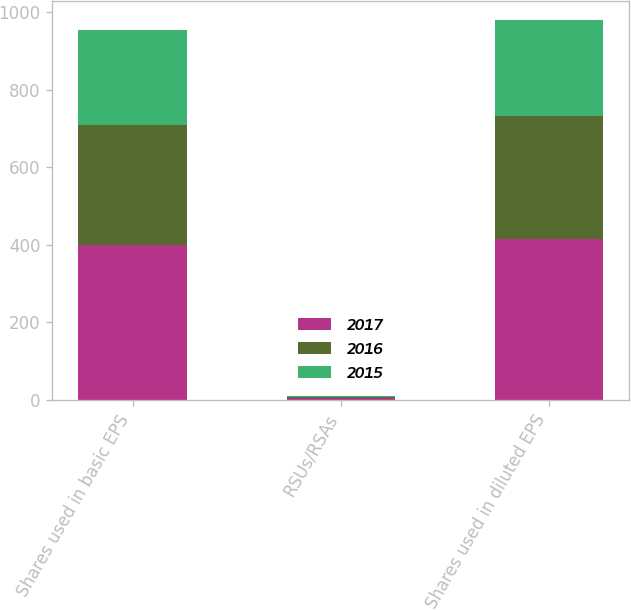Convert chart to OTSL. <chart><loc_0><loc_0><loc_500><loc_500><stacked_bar_chart><ecel><fcel>Shares used in basic EPS<fcel>RSUs/RSAs<fcel>Shares used in diluted EPS<nl><fcel>2017<fcel>400.3<fcel>5<fcel>416.2<nl><fcel>2016<fcel>309.2<fcel>3.2<fcel>316.3<nl><fcel>2015<fcel>243.4<fcel>3<fcel>246.4<nl></chart> 